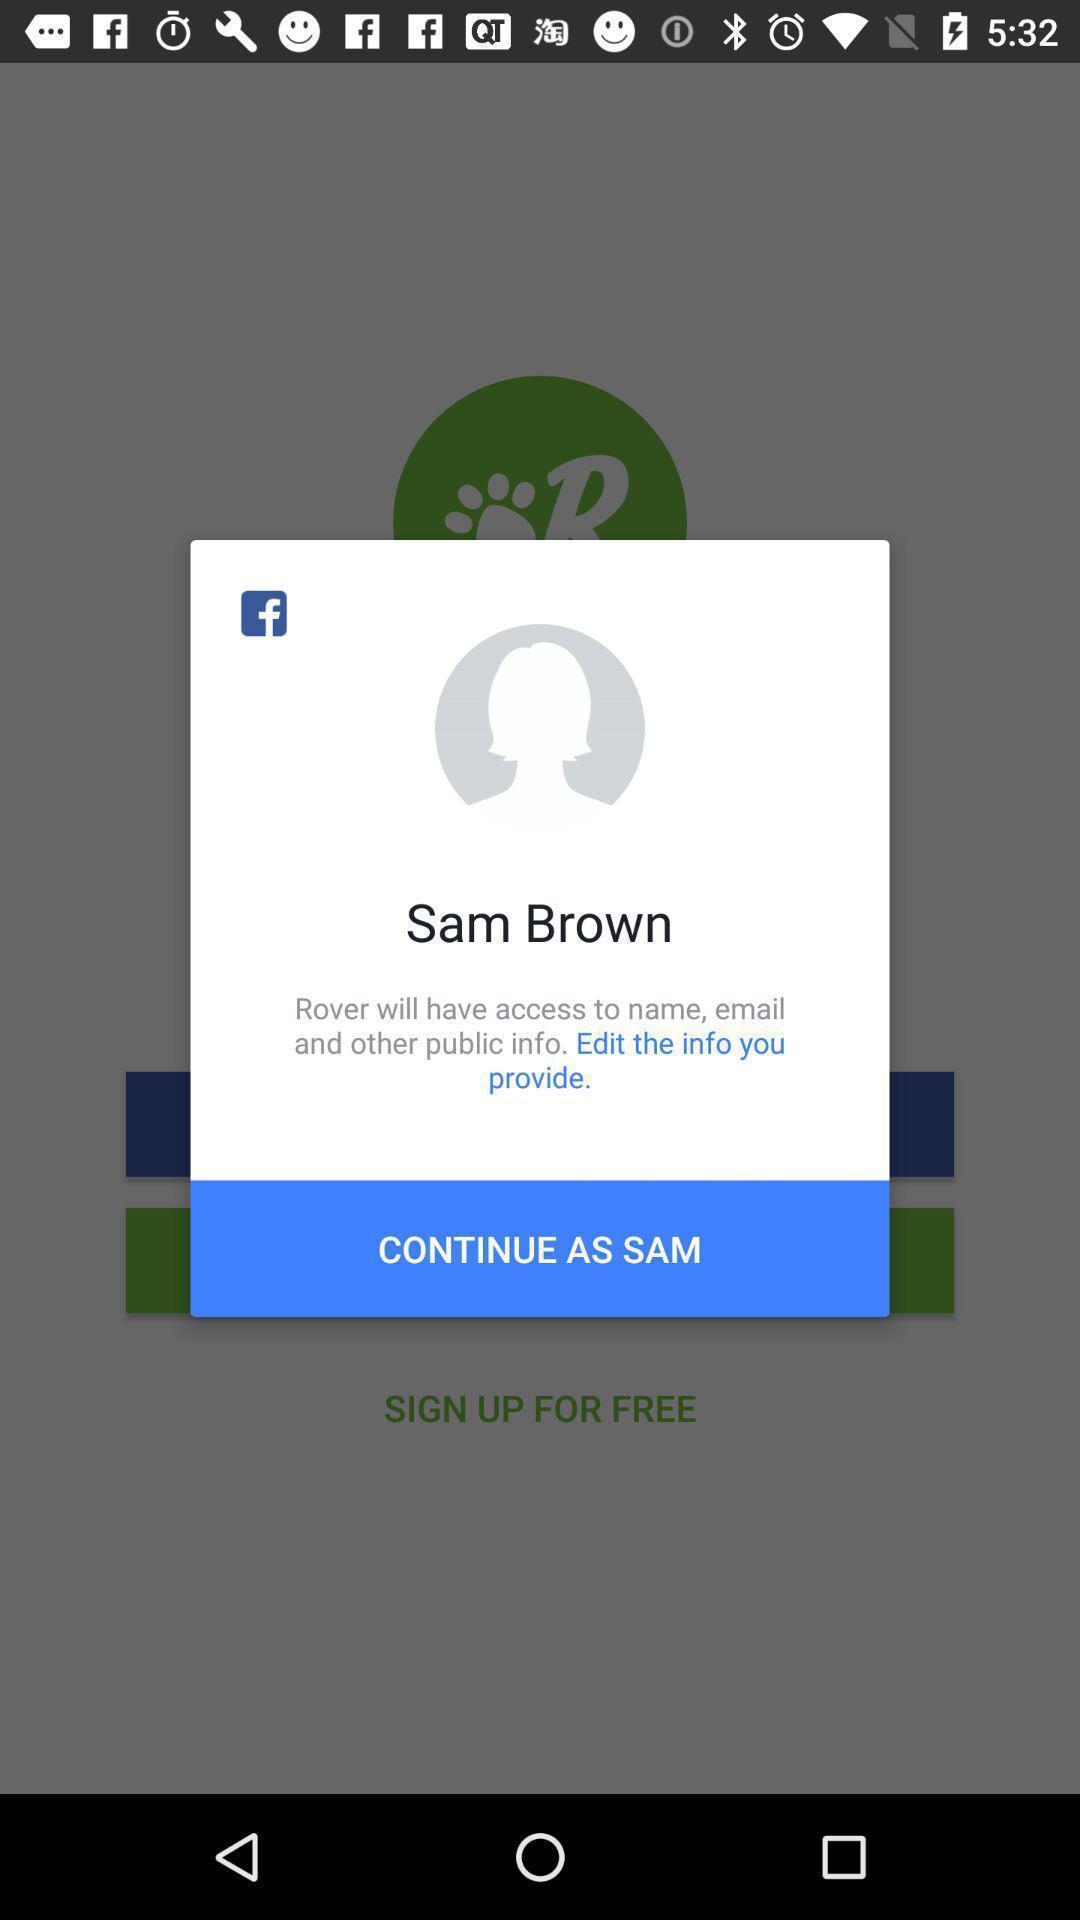Explain what's happening in this screen capture. Pop-up showing to continue in social app. 